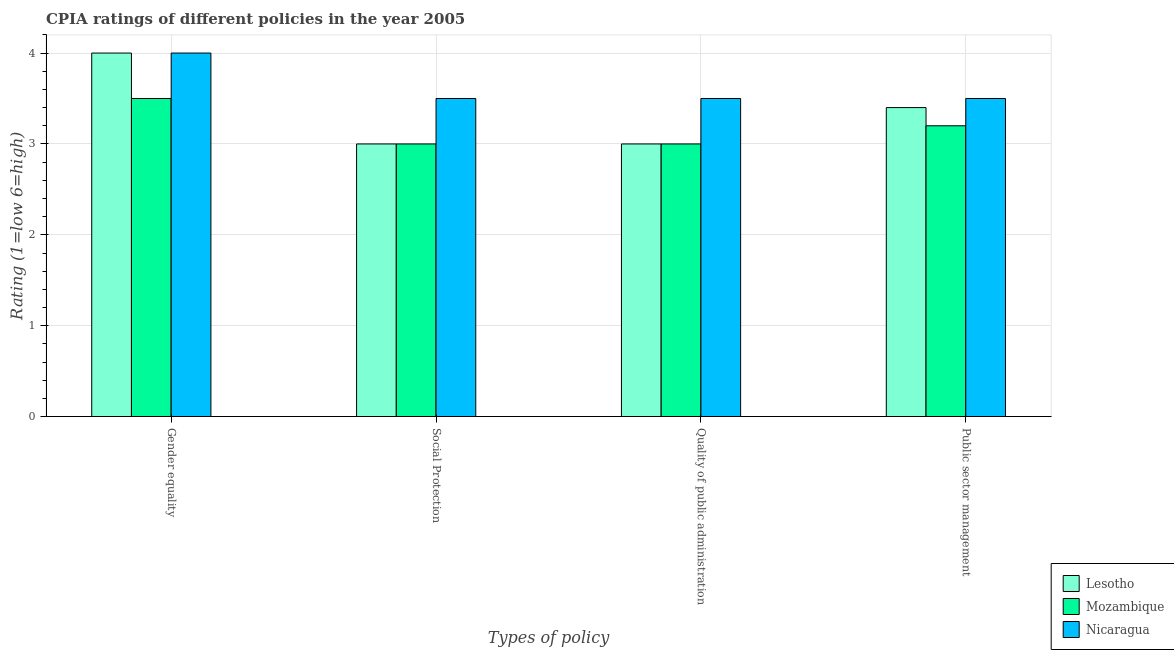How many different coloured bars are there?
Provide a short and direct response. 3. Are the number of bars on each tick of the X-axis equal?
Your answer should be very brief. Yes. How many bars are there on the 3rd tick from the right?
Provide a short and direct response. 3. What is the label of the 1st group of bars from the left?
Provide a succinct answer. Gender equality. In which country was the cpia rating of social protection maximum?
Offer a very short reply. Nicaragua. In which country was the cpia rating of social protection minimum?
Make the answer very short. Lesotho. What is the difference between the cpia rating of public sector management in Nicaragua and the cpia rating of quality of public administration in Lesotho?
Your response must be concise. 0.5. What is the average cpia rating of quality of public administration per country?
Offer a terse response. 3.17. What is the difference between the cpia rating of social protection and cpia rating of quality of public administration in Nicaragua?
Provide a short and direct response. 0. What is the ratio of the cpia rating of public sector management in Nicaragua to that in Lesotho?
Make the answer very short. 1.03. What is the difference between the highest and the second highest cpia rating of social protection?
Your answer should be compact. 0.5. What is the difference between the highest and the lowest cpia rating of social protection?
Give a very brief answer. 0.5. In how many countries, is the cpia rating of quality of public administration greater than the average cpia rating of quality of public administration taken over all countries?
Give a very brief answer. 1. Is the sum of the cpia rating of social protection in Mozambique and Nicaragua greater than the maximum cpia rating of quality of public administration across all countries?
Provide a short and direct response. Yes. Is it the case that in every country, the sum of the cpia rating of gender equality and cpia rating of public sector management is greater than the sum of cpia rating of social protection and cpia rating of quality of public administration?
Provide a succinct answer. Yes. What does the 1st bar from the left in Social Protection represents?
Your answer should be very brief. Lesotho. What does the 1st bar from the right in Social Protection represents?
Ensure brevity in your answer.  Nicaragua. Is it the case that in every country, the sum of the cpia rating of gender equality and cpia rating of social protection is greater than the cpia rating of quality of public administration?
Provide a succinct answer. Yes. How many bars are there?
Ensure brevity in your answer.  12. What is the difference between two consecutive major ticks on the Y-axis?
Offer a terse response. 1. Does the graph contain any zero values?
Keep it short and to the point. No. Does the graph contain grids?
Provide a short and direct response. Yes. How many legend labels are there?
Give a very brief answer. 3. How are the legend labels stacked?
Keep it short and to the point. Vertical. What is the title of the graph?
Provide a short and direct response. CPIA ratings of different policies in the year 2005. What is the label or title of the X-axis?
Keep it short and to the point. Types of policy. What is the Rating (1=low 6=high) in Lesotho in Gender equality?
Offer a terse response. 4. What is the Rating (1=low 6=high) in Lesotho in Social Protection?
Offer a very short reply. 3. What is the Rating (1=low 6=high) in Mozambique in Quality of public administration?
Provide a short and direct response. 3. What is the Rating (1=low 6=high) in Nicaragua in Quality of public administration?
Your answer should be very brief. 3.5. What is the Rating (1=low 6=high) of Nicaragua in Public sector management?
Give a very brief answer. 3.5. Across all Types of policy, what is the maximum Rating (1=low 6=high) of Lesotho?
Make the answer very short. 4. Across all Types of policy, what is the maximum Rating (1=low 6=high) in Mozambique?
Provide a succinct answer. 3.5. Across all Types of policy, what is the minimum Rating (1=low 6=high) in Nicaragua?
Your answer should be very brief. 3.5. What is the difference between the Rating (1=low 6=high) in Lesotho in Gender equality and that in Social Protection?
Provide a short and direct response. 1. What is the difference between the Rating (1=low 6=high) in Mozambique in Gender equality and that in Social Protection?
Make the answer very short. 0.5. What is the difference between the Rating (1=low 6=high) of Nicaragua in Gender equality and that in Social Protection?
Offer a terse response. 0.5. What is the difference between the Rating (1=low 6=high) of Nicaragua in Gender equality and that in Quality of public administration?
Offer a terse response. 0.5. What is the difference between the Rating (1=low 6=high) in Lesotho in Gender equality and that in Public sector management?
Provide a short and direct response. 0.6. What is the difference between the Rating (1=low 6=high) in Lesotho in Social Protection and that in Quality of public administration?
Make the answer very short. 0. What is the difference between the Rating (1=low 6=high) in Nicaragua in Social Protection and that in Quality of public administration?
Keep it short and to the point. 0. What is the difference between the Rating (1=low 6=high) of Nicaragua in Social Protection and that in Public sector management?
Ensure brevity in your answer.  0. What is the difference between the Rating (1=low 6=high) of Nicaragua in Quality of public administration and that in Public sector management?
Provide a short and direct response. 0. What is the difference between the Rating (1=low 6=high) in Mozambique in Gender equality and the Rating (1=low 6=high) in Nicaragua in Social Protection?
Provide a short and direct response. 0. What is the difference between the Rating (1=low 6=high) of Mozambique in Gender equality and the Rating (1=low 6=high) of Nicaragua in Quality of public administration?
Keep it short and to the point. 0. What is the difference between the Rating (1=low 6=high) of Lesotho in Gender equality and the Rating (1=low 6=high) of Mozambique in Public sector management?
Ensure brevity in your answer.  0.8. What is the difference between the Rating (1=low 6=high) of Lesotho in Gender equality and the Rating (1=low 6=high) of Nicaragua in Public sector management?
Give a very brief answer. 0.5. What is the difference between the Rating (1=low 6=high) in Mozambique in Gender equality and the Rating (1=low 6=high) in Nicaragua in Public sector management?
Make the answer very short. 0. What is the difference between the Rating (1=low 6=high) of Lesotho in Social Protection and the Rating (1=low 6=high) of Nicaragua in Quality of public administration?
Keep it short and to the point. -0.5. What is the difference between the Rating (1=low 6=high) of Lesotho in Social Protection and the Rating (1=low 6=high) of Mozambique in Public sector management?
Your response must be concise. -0.2. What is the difference between the Rating (1=low 6=high) of Mozambique in Social Protection and the Rating (1=low 6=high) of Nicaragua in Public sector management?
Your answer should be compact. -0.5. What is the difference between the Rating (1=low 6=high) of Lesotho in Quality of public administration and the Rating (1=low 6=high) of Mozambique in Public sector management?
Offer a very short reply. -0.2. What is the difference between the Rating (1=low 6=high) of Lesotho in Quality of public administration and the Rating (1=low 6=high) of Nicaragua in Public sector management?
Provide a succinct answer. -0.5. What is the difference between the Rating (1=low 6=high) in Mozambique in Quality of public administration and the Rating (1=low 6=high) in Nicaragua in Public sector management?
Your response must be concise. -0.5. What is the average Rating (1=low 6=high) in Lesotho per Types of policy?
Give a very brief answer. 3.35. What is the average Rating (1=low 6=high) in Mozambique per Types of policy?
Provide a succinct answer. 3.17. What is the average Rating (1=low 6=high) in Nicaragua per Types of policy?
Your response must be concise. 3.62. What is the difference between the Rating (1=low 6=high) of Lesotho and Rating (1=low 6=high) of Mozambique in Social Protection?
Make the answer very short. 0. What is the difference between the Rating (1=low 6=high) in Lesotho and Rating (1=low 6=high) in Nicaragua in Social Protection?
Your answer should be very brief. -0.5. What is the difference between the Rating (1=low 6=high) of Mozambique and Rating (1=low 6=high) of Nicaragua in Social Protection?
Keep it short and to the point. -0.5. What is the difference between the Rating (1=low 6=high) in Mozambique and Rating (1=low 6=high) in Nicaragua in Quality of public administration?
Your answer should be compact. -0.5. What is the difference between the Rating (1=low 6=high) in Lesotho and Rating (1=low 6=high) in Nicaragua in Public sector management?
Provide a short and direct response. -0.1. What is the ratio of the Rating (1=low 6=high) of Lesotho in Gender equality to that in Social Protection?
Your answer should be compact. 1.33. What is the ratio of the Rating (1=low 6=high) in Lesotho in Gender equality to that in Public sector management?
Your response must be concise. 1.18. What is the ratio of the Rating (1=low 6=high) in Mozambique in Gender equality to that in Public sector management?
Give a very brief answer. 1.09. What is the ratio of the Rating (1=low 6=high) in Mozambique in Social Protection to that in Quality of public administration?
Give a very brief answer. 1. What is the ratio of the Rating (1=low 6=high) in Nicaragua in Social Protection to that in Quality of public administration?
Make the answer very short. 1. What is the ratio of the Rating (1=low 6=high) in Lesotho in Social Protection to that in Public sector management?
Keep it short and to the point. 0.88. What is the ratio of the Rating (1=low 6=high) of Lesotho in Quality of public administration to that in Public sector management?
Make the answer very short. 0.88. What is the difference between the highest and the second highest Rating (1=low 6=high) of Lesotho?
Your response must be concise. 0.6. What is the difference between the highest and the lowest Rating (1=low 6=high) in Lesotho?
Your answer should be compact. 1. What is the difference between the highest and the lowest Rating (1=low 6=high) of Nicaragua?
Offer a very short reply. 0.5. 